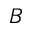<formula> <loc_0><loc_0><loc_500><loc_500>B</formula> 